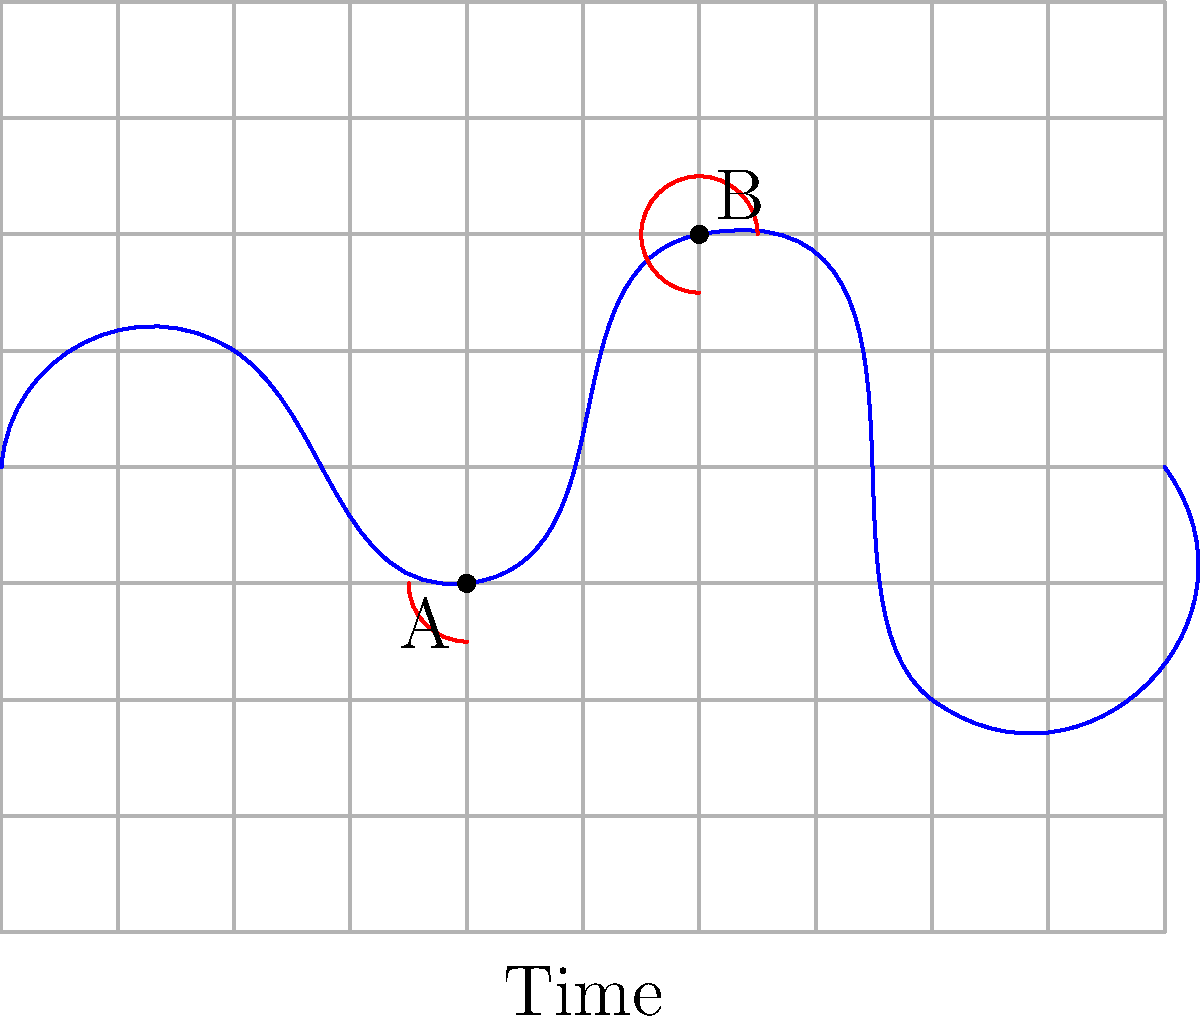In the freezer temperature monitoring chart above, angles are formed by the temperature curve at points A and B. These angles appear to be congruent. What property of congruent angles can be used to verify this observation, and how might it relate to maintaining consistent freezer temperatures? To verify if the angles at points A and B are congruent, we can use the following steps:

1. Congruent angles have equal measure. In this case, we need to compare the angles formed by the tangent lines at points A and B with the horizontal axis.

2. The tangent line at a point on a curve is perpendicular to the normal line at that point. The normal line bisects the angle between the incoming and outgoing segments of the curve.

3. At point A, the curve changes from decreasing to increasing, forming a local minimum. At point B, the curve changes from increasing to decreasing, forming a local maximum.

4. The angles formed at these turning points (local minimum and maximum) are supplementary to each other, meaning they add up to 180°.

5. If we consider the angles formed by the tangent lines with the horizontal axis, they would be complementary to the angles formed by the curve. Complementary angles add up to 90°.

6. Since both angles at A and B are formed at turning points and are complementary to supplementary angles, they must be equal and therefore congruent.

Relating this to freezer temperature maintenance:

7. Congruent angles in the temperature curve might indicate similar rates of temperature change at different points in time.

8. For a concerned parent and food safety advocate, recognizing these patterns can help in:
   a) Identifying regular defrost cycles
   b) Detecting potential issues with the freezer's cooling system
   c) Ensuring consistent temperature control for food safety

9. Maintaining consistent freezer temperatures is crucial for preserving food quality and preventing bacterial growth, which aligns with the persona's interests in food safety.
Answer: Complementary angles to supplementary angles at curve turning points 